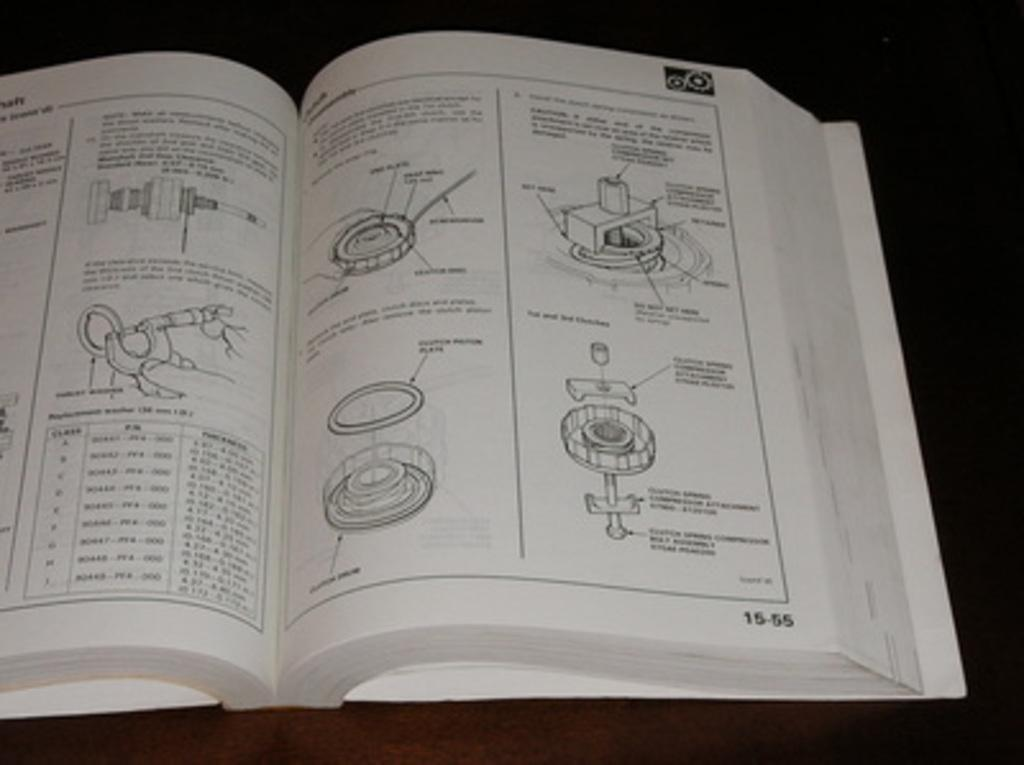What is the main object in the image? There is a book in the image. What type of content is in the book? The book contains diagrams. What can be observed about the background of the image? The background of the image is dark. How many sons are visible in the image? There are no sons present in the image; it only features a book with diagrams and a dark background. 